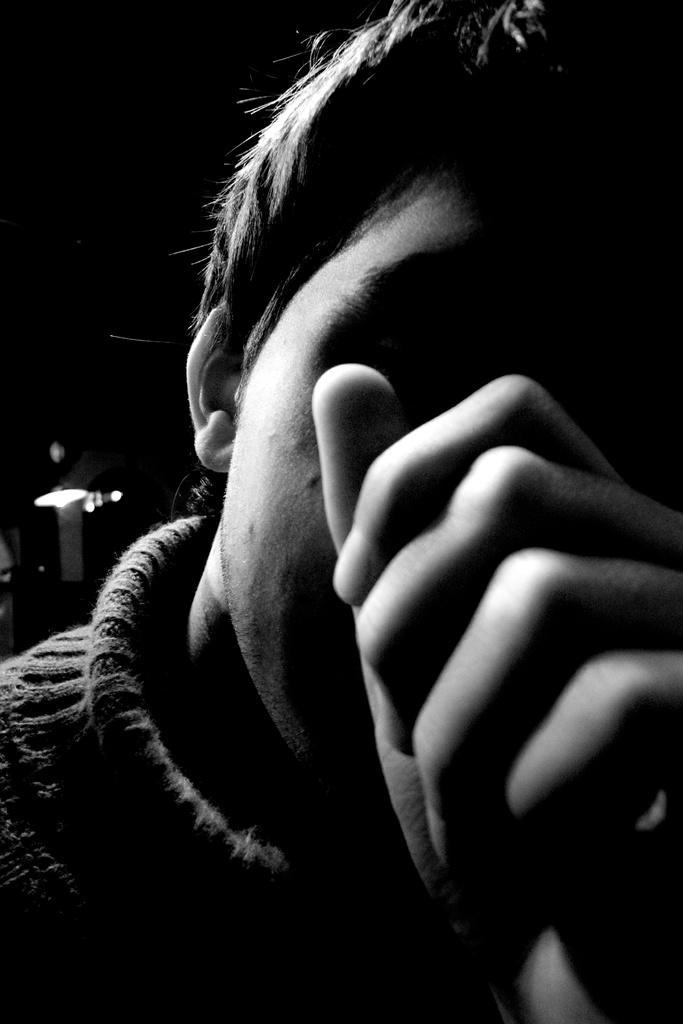How would you summarize this image in a sentence or two? This is a black and white picture, there is a person in the front in sweatshirt, in the back there is light over the ceiling. 